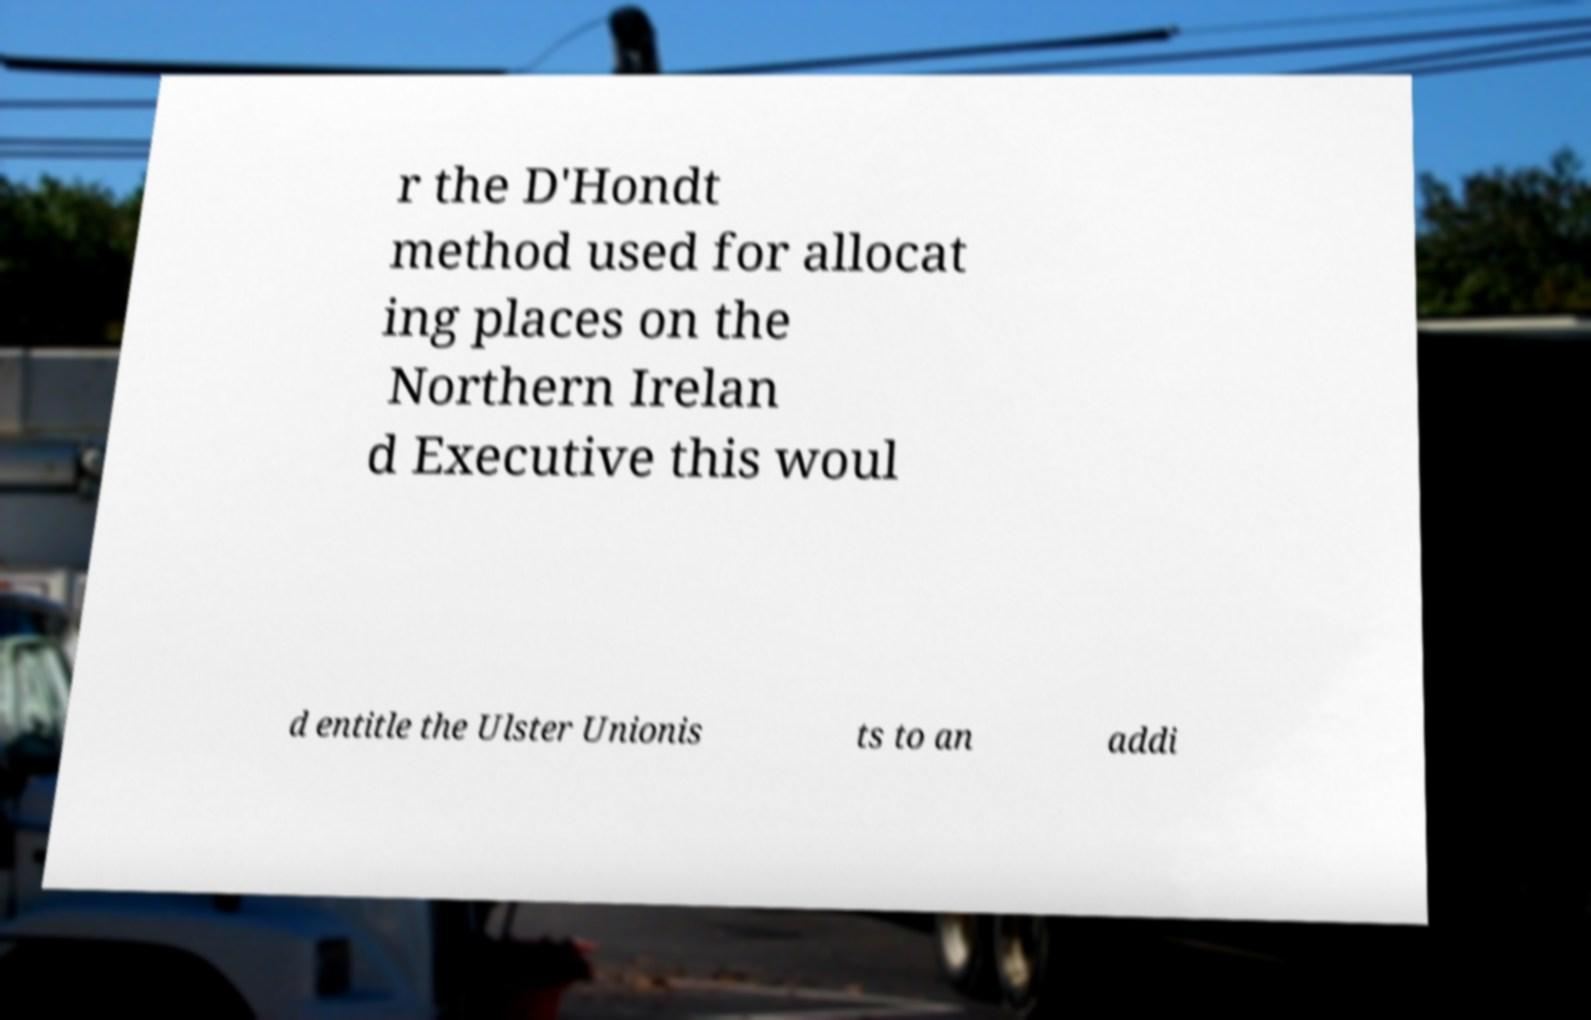Can you read and provide the text displayed in the image?This photo seems to have some interesting text. Can you extract and type it out for me? r the D'Hondt method used for allocat ing places on the Northern Irelan d Executive this woul d entitle the Ulster Unionis ts to an addi 